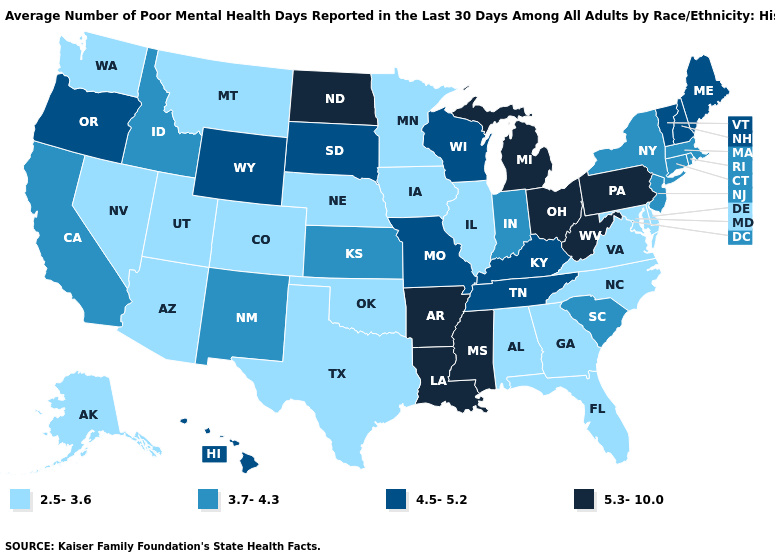Name the states that have a value in the range 4.5-5.2?
Give a very brief answer. Hawaii, Kentucky, Maine, Missouri, New Hampshire, Oregon, South Dakota, Tennessee, Vermont, Wisconsin, Wyoming. Is the legend a continuous bar?
Concise answer only. No. Does Washington have a lower value than Alaska?
Short answer required. No. Name the states that have a value in the range 2.5-3.6?
Write a very short answer. Alabama, Alaska, Arizona, Colorado, Delaware, Florida, Georgia, Illinois, Iowa, Maryland, Minnesota, Montana, Nebraska, Nevada, North Carolina, Oklahoma, Texas, Utah, Virginia, Washington. Is the legend a continuous bar?
Quick response, please. No. What is the value of Washington?
Be succinct. 2.5-3.6. Name the states that have a value in the range 4.5-5.2?
Keep it brief. Hawaii, Kentucky, Maine, Missouri, New Hampshire, Oregon, South Dakota, Tennessee, Vermont, Wisconsin, Wyoming. Does Washington have a lower value than Alabama?
Be succinct. No. Does Delaware have the lowest value in the USA?
Answer briefly. Yes. Name the states that have a value in the range 4.5-5.2?
Be succinct. Hawaii, Kentucky, Maine, Missouri, New Hampshire, Oregon, South Dakota, Tennessee, Vermont, Wisconsin, Wyoming. Among the states that border Iowa , which have the lowest value?
Short answer required. Illinois, Minnesota, Nebraska. What is the value of Iowa?
Give a very brief answer. 2.5-3.6. Name the states that have a value in the range 3.7-4.3?
Concise answer only. California, Connecticut, Idaho, Indiana, Kansas, Massachusetts, New Jersey, New Mexico, New York, Rhode Island, South Carolina. Does New Jersey have the highest value in the USA?
Quick response, please. No. 